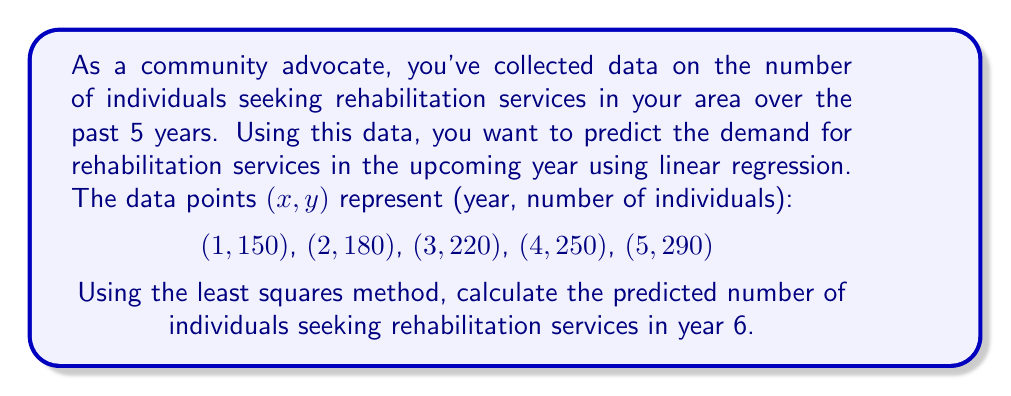Help me with this question. To solve this problem, we'll use linear regression with the least squares method:

1) First, we need to calculate the following sums:
   $\sum x = 1 + 2 + 3 + 4 + 5 = 15$
   $\sum y = 150 + 180 + 220 + 250 + 290 = 1090$
   $\sum xy = (1)(150) + (2)(180) + (3)(220) + (4)(250) + (5)(290) = 3460$
   $\sum x^2 = 1^2 + 2^2 + 3^2 + 4^2 + 5^2 = 55$
   $n = 5$ (number of data points)

2) Now, we can use these formulas to find the slope (m) and y-intercept (b):
   $$m = \frac{n\sum xy - \sum x \sum y}{n\sum x^2 - (\sum x)^2}$$
   $$b = \frac{\sum y - m\sum x}{n}$$

3) Let's calculate m:
   $$m = \frac{5(3460) - (15)(1090)}{5(55) - (15)^2} = \frac{17300 - 16350}{275 - 225} = \frac{950}{50} = 35$$

4) Now let's calculate b:
   $$b = \frac{1090 - 35(15)}{5} = \frac{1090 - 525}{5} = 113$$

5) Our regression line equation is:
   $$y = 35x + 113$$

6) To predict the number of individuals for year 6, we substitute x = 6:
   $$y = 35(6) + 113 = 210 + 113 = 323$$

Therefore, the predicted number of individuals seeking rehabilitation services in year 6 is 323.
Answer: 323 individuals 